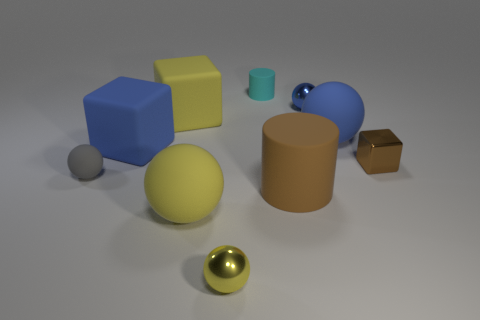Subtract 1 spheres. How many spheres are left? 4 Subtract all cylinders. How many objects are left? 8 Add 3 big things. How many big things are left? 8 Add 7 big yellow rubber balls. How many big yellow rubber balls exist? 8 Subtract 2 blue balls. How many objects are left? 8 Subtract all tiny yellow metal things. Subtract all tiny rubber spheres. How many objects are left? 8 